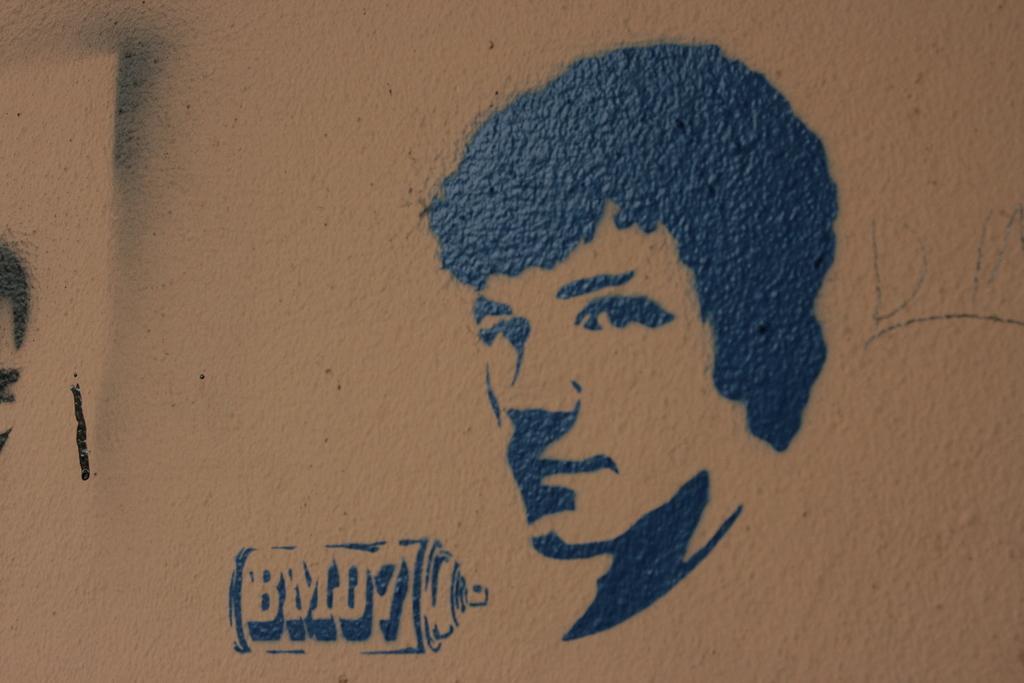How would you summarize this image in a sentence or two? In the picture there is a wall, on the wall there is a person's painting. On the left there is another painting. 